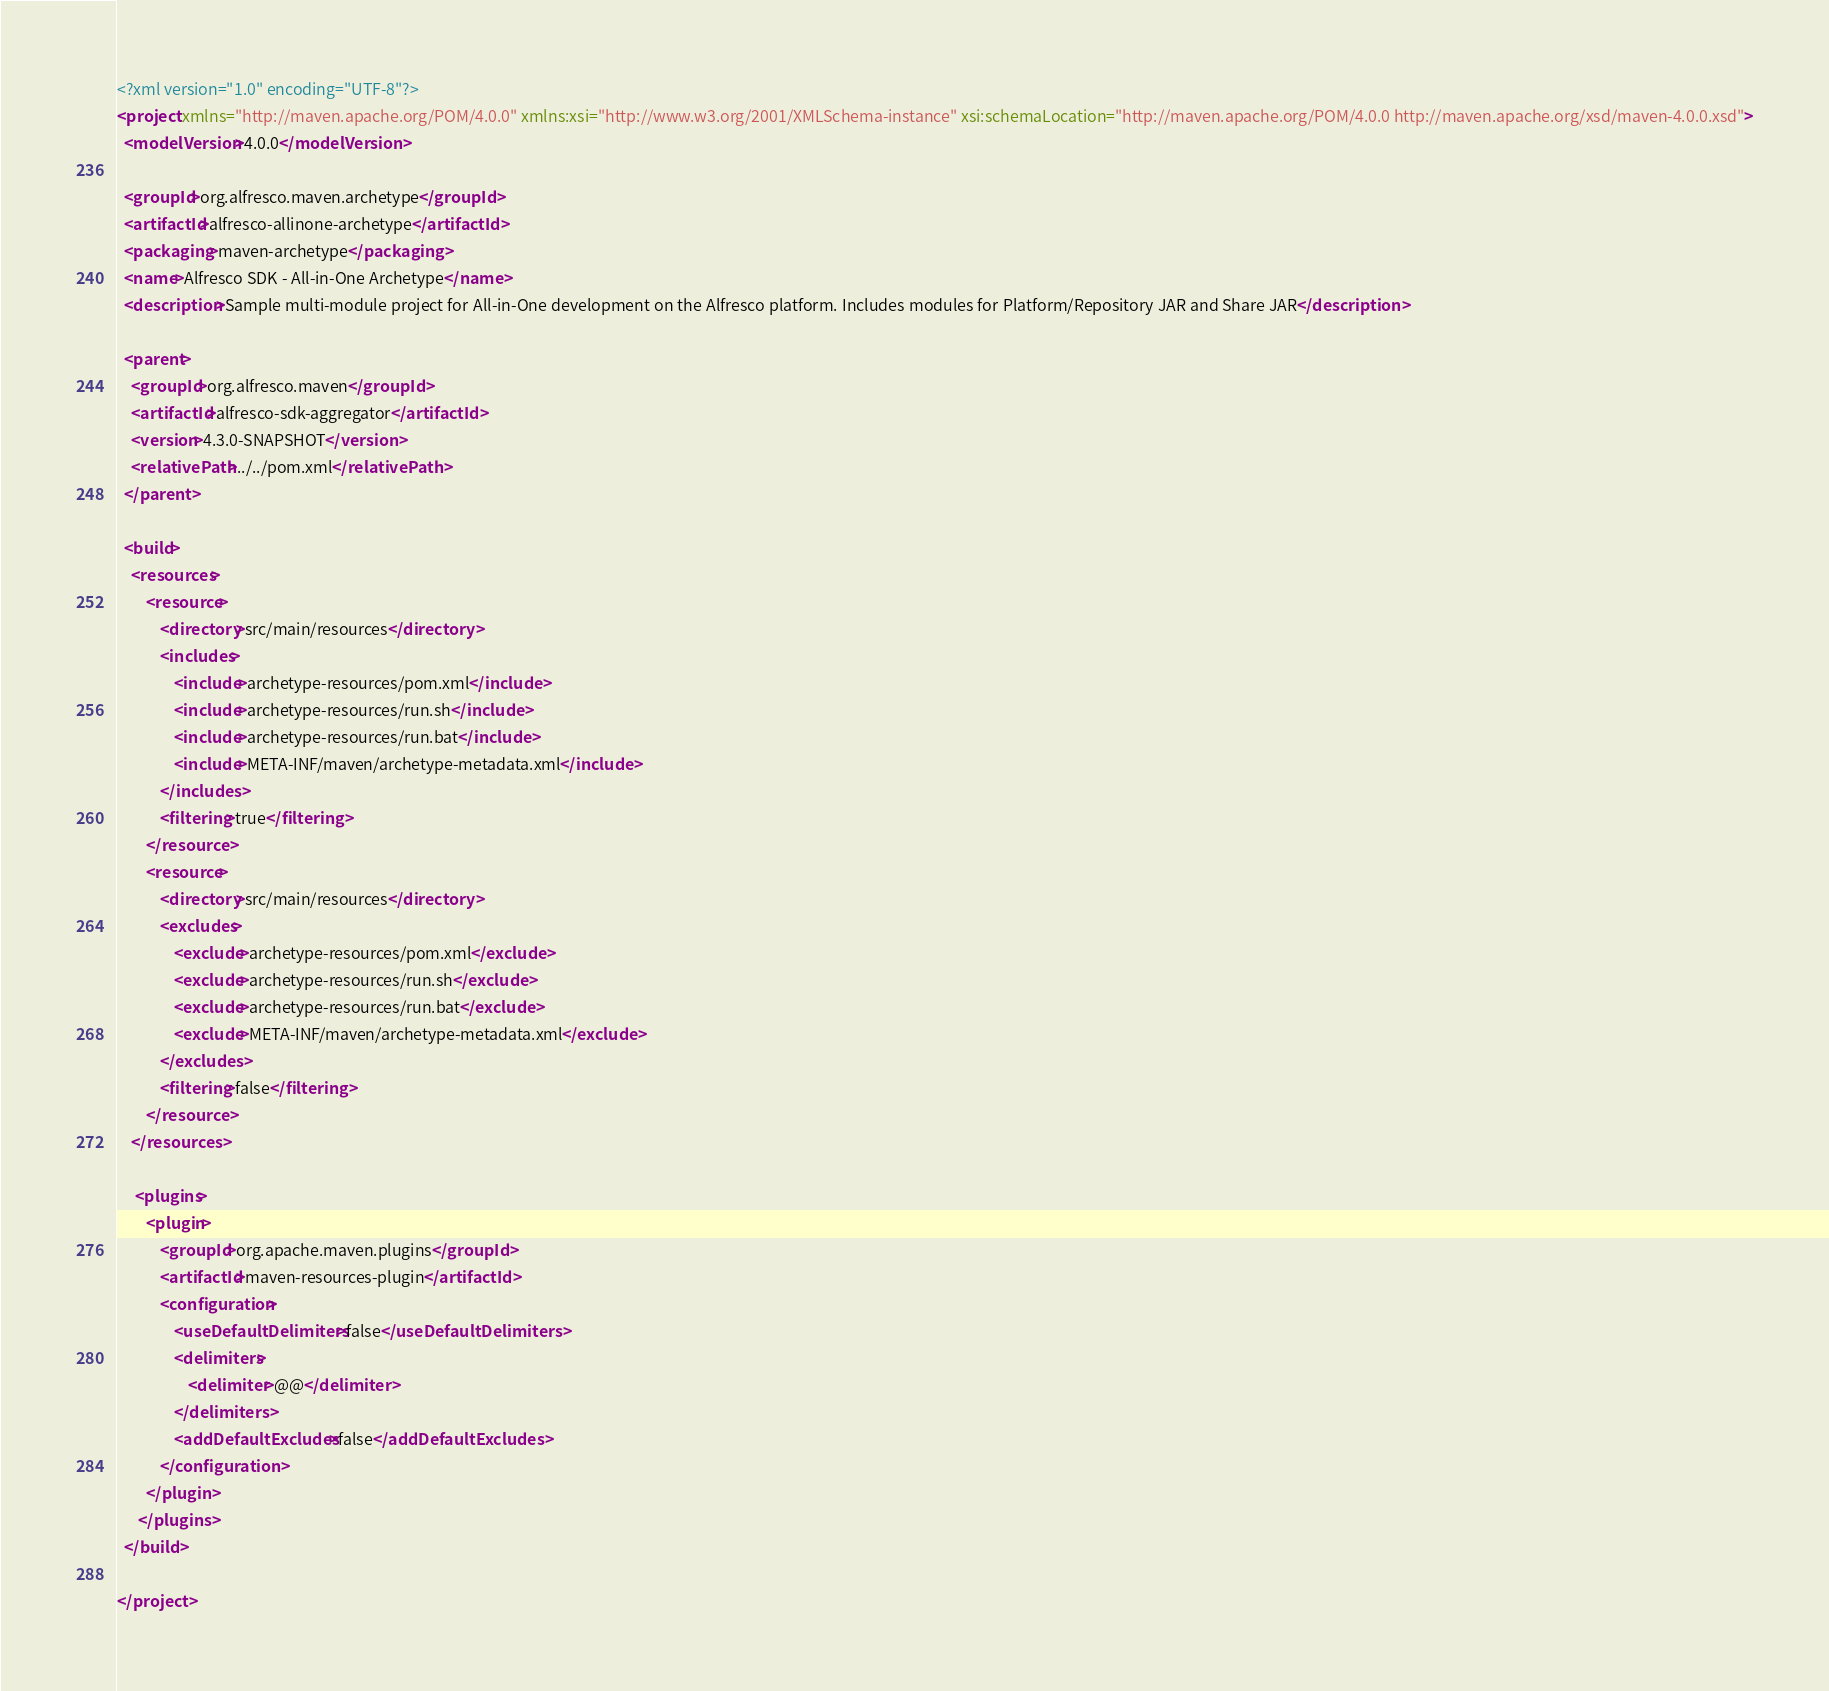<code> <loc_0><loc_0><loc_500><loc_500><_XML_><?xml version="1.0" encoding="UTF-8"?>
<project xmlns="http://maven.apache.org/POM/4.0.0" xmlns:xsi="http://www.w3.org/2001/XMLSchema-instance" xsi:schemaLocation="http://maven.apache.org/POM/4.0.0 http://maven.apache.org/xsd/maven-4.0.0.xsd">
  <modelVersion>4.0.0</modelVersion>

  <groupId>org.alfresco.maven.archetype</groupId>
  <artifactId>alfresco-allinone-archetype</artifactId>
  <packaging>maven-archetype</packaging>
  <name>Alfresco SDK - All-in-One Archetype</name>
  <description>Sample multi-module project for All-in-One development on the Alfresco platform. Includes modules for Platform/Repository JAR and Share JAR</description>

  <parent>
    <groupId>org.alfresco.maven</groupId>
    <artifactId>alfresco-sdk-aggregator</artifactId>
    <version>4.3.0-SNAPSHOT</version>
    <relativePath>../../pom.xml</relativePath>
  </parent>

  <build>
    <resources>
        <resource>
            <directory>src/main/resources</directory>
            <includes>
                <include>archetype-resources/pom.xml</include>
                <include>archetype-resources/run.sh</include>
                <include>archetype-resources/run.bat</include>
                <include>META-INF/maven/archetype-metadata.xml</include>
            </includes>
            <filtering>true</filtering>
        </resource>
        <resource>
            <directory>src/main/resources</directory>
            <excludes>
                <exclude>archetype-resources/pom.xml</exclude>
                <exclude>archetype-resources/run.sh</exclude>
                <exclude>archetype-resources/run.bat</exclude>
                <exclude>META-INF/maven/archetype-metadata.xml</exclude>
            </excludes>
            <filtering>false</filtering>
        </resource>
    </resources>

     <plugins>
        <plugin>
            <groupId>org.apache.maven.plugins</groupId>
            <artifactId>maven-resources-plugin</artifactId>
            <configuration>
                <useDefaultDelimiters>false</useDefaultDelimiters>
                <delimiters>
                    <delimiter>@@</delimiter>
                </delimiters>
                <addDefaultExcludes>false</addDefaultExcludes>
            </configuration>
        </plugin>
      </plugins>
  </build>

</project>
</code> 